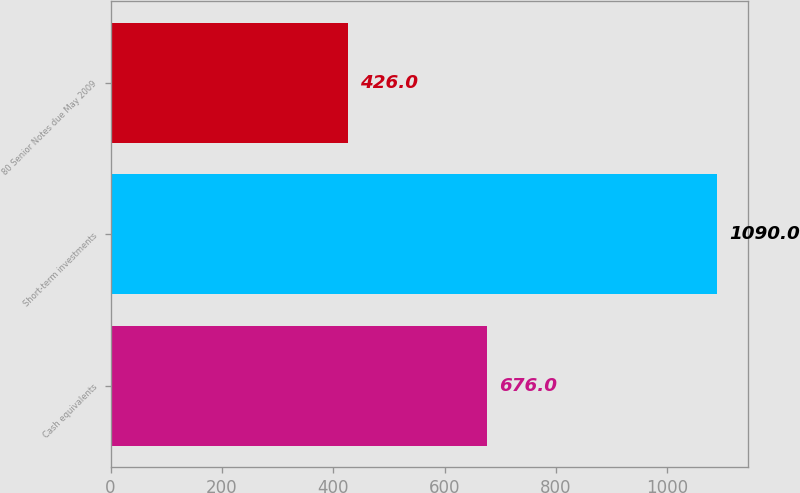Convert chart to OTSL. <chart><loc_0><loc_0><loc_500><loc_500><bar_chart><fcel>Cash equivalents<fcel>Short-term investments<fcel>80 Senior Notes due May 2009<nl><fcel>676<fcel>1090<fcel>426<nl></chart> 